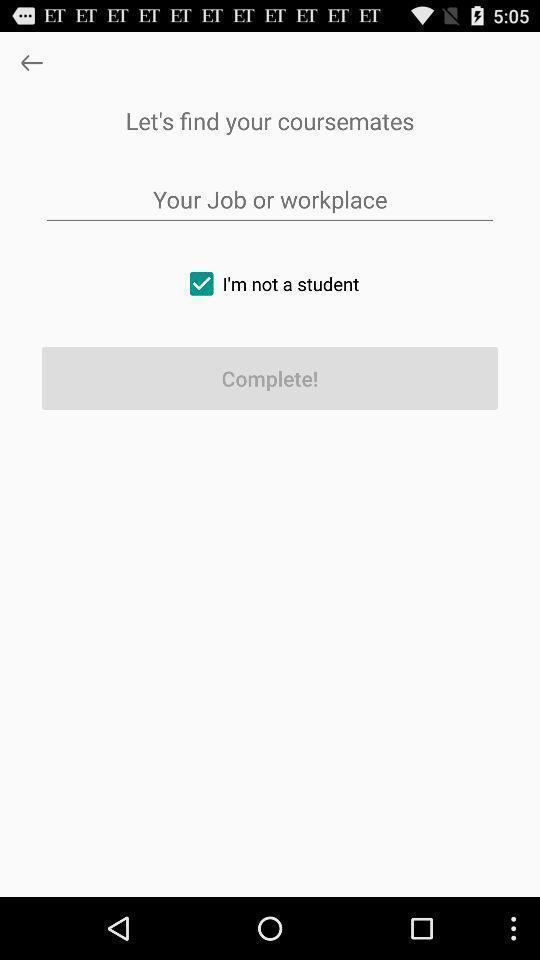Explain what's happening in this screen capture. Welcome page of a coursemate app. 